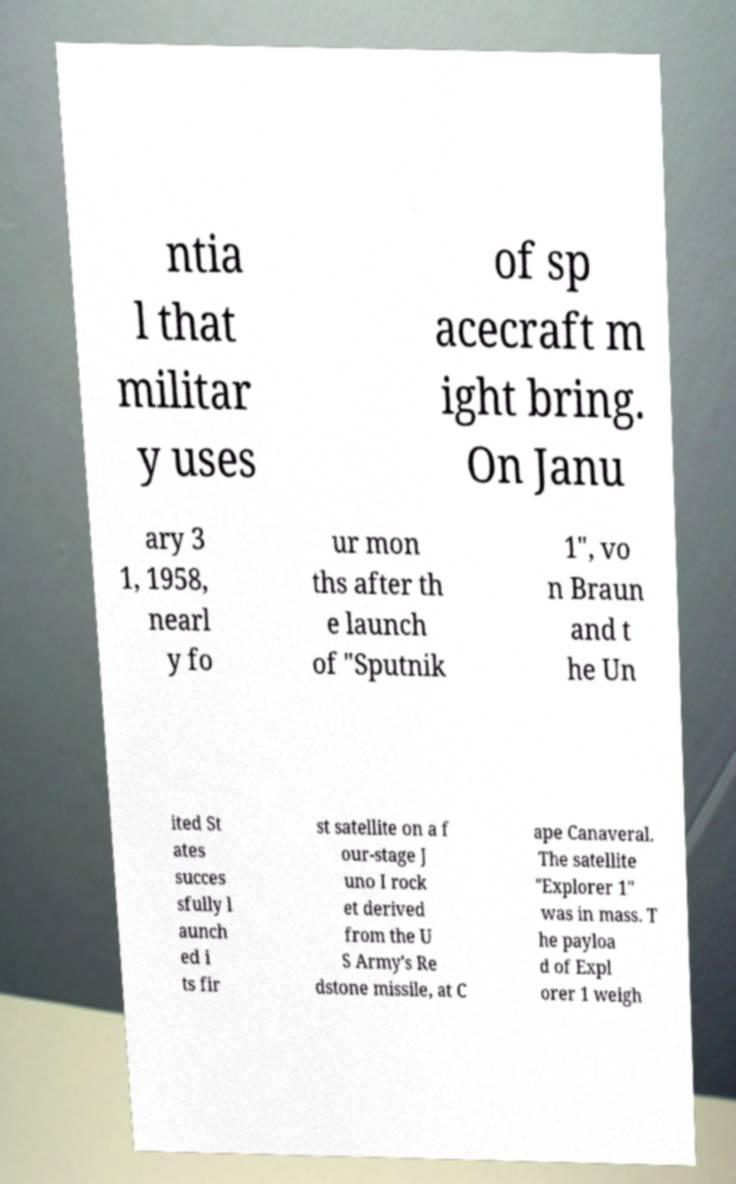What messages or text are displayed in this image? I need them in a readable, typed format. ntia l that militar y uses of sp acecraft m ight bring. On Janu ary 3 1, 1958, nearl y fo ur mon ths after th e launch of "Sputnik 1", vo n Braun and t he Un ited St ates succes sfully l aunch ed i ts fir st satellite on a f our-stage J uno I rock et derived from the U S Army's Re dstone missile, at C ape Canaveral. The satellite "Explorer 1" was in mass. T he payloa d of Expl orer 1 weigh 